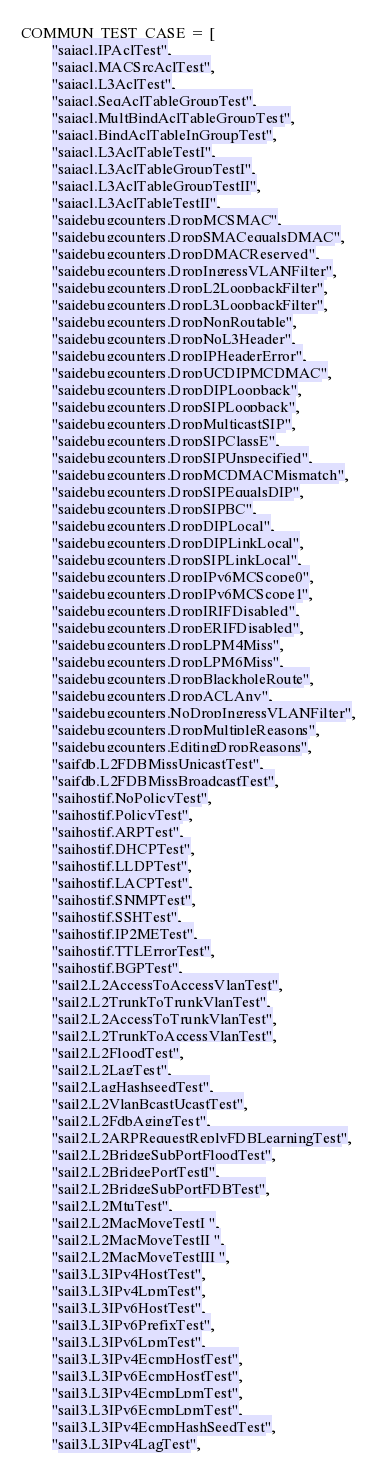<code> <loc_0><loc_0><loc_500><loc_500><_Python_>COMMUN_TEST_CASE = [
        "saiacl.IPAclTest",
        "saiacl.MACSrcAclTest",
        "saiacl.L3AclTest",
        "saiacl.SeqAclTableGroupTest",
        "saiacl.MultBindAclTableGroupTest",
        "saiacl.BindAclTableInGroupTest",
        "saiacl.L3AclTableTestI",
        "saiacl.L3AclTableGroupTestI",
        "saiacl.L3AclTableGroupTestII",
        "saiacl.L3AclTableTestII",
        "saidebugcounters.DropMCSMAC",
        "saidebugcounters.DropSMACequalsDMAC",
        "saidebugcounters.DropDMACReserved",
        "saidebugcounters.DropIngressVLANFilter",
        "saidebugcounters.DropL2LoopbackFilter",
        "saidebugcounters.DropL3LoopbackFilter",
        "saidebugcounters.DropNonRoutable",
        "saidebugcounters.DropNoL3Header",
        "saidebugcounters.DropIPHeaderError",
        "saidebugcounters.DropUCDIPMCDMAC",
        "saidebugcounters.DropDIPLoopback",
        "saidebugcounters.DropSIPLoopback",
        "saidebugcounters.DropMulticastSIP",
        "saidebugcounters.DropSIPClassE",
        "saidebugcounters.DropSIPUnspecified",
        "saidebugcounters.DropMCDMACMismatch",
        "saidebugcounters.DropSIPEqualsDIP",
        "saidebugcounters.DropSIPBC",
        "saidebugcounters.DropDIPLocal",
        "saidebugcounters.DropDIPLinkLocal",
        "saidebugcounters.DropSIPLinkLocal",
        "saidebugcounters.DropIPv6MCScope0",
        "saidebugcounters.DropIPv6MCScope1",
        "saidebugcounters.DropIRIFDisabled",
        "saidebugcounters.DropERIFDisabled",
        "saidebugcounters.DropLPM4Miss",
        "saidebugcounters.DropLPM6Miss",
        "saidebugcounters.DropBlackholeRoute",
        "saidebugcounters.DropACLAny",
        "saidebugcounters.NoDropIngressVLANFilter",
        "saidebugcounters.DropMultipleReasons",
        "saidebugcounters.EditingDropReasons",
        "saifdb.L2FDBMissUnicastTest",
        "saifdb.L2FDBMissBroadcastTest",
        "saihostif.NoPolicyTest",
        "saihostif.PolicyTest",
        "saihostif.ARPTest",
        "saihostif.DHCPTest",
        "saihostif.LLDPTest",
        "saihostif.LACPTest",
        "saihostif.SNMPTest",
        "saihostif.SSHTest",
        "saihostif.IP2METest",
        "saihostif.TTLErrorTest",
        "saihostif.BGPTest",
        "sail2.L2AccessToAccessVlanTest",
        "sail2.L2TrunkToTrunkVlanTest",
        "sail2.L2AccessToTrunkVlanTest",
        "sail2.L2TrunkToAccessVlanTest",
        "sail2.L2FloodTest",
        "sail2.L2LagTest",
        "sail2.LagHashseedTest",
        "sail2.L2VlanBcastUcastTest",
        "sail2.L2FdbAgingTest",
        "sail2.L2ARPRequestReplyFDBLearningTest",
        "sail2.L2BridgeSubPortFloodTest",
        "sail2.L2BridgePortTestI",
        "sail2.L2BridgeSubPortFDBTest",
        "sail2.L2MtuTest",
        "sail2.L2MacMoveTestI ",
        "sail2.L2MacMoveTestII ",
        "sail2.L2MacMoveTestIII ",
        "sail3.L3IPv4HostTest",
        "sail3.L3IPv4LpmTest",
        "sail3.L3IPv6HostTest",
        "sail3.L3IPv6PrefixTest",
        "sail3.L3IPv6LpmTest",
        "sail3.L3IPv4EcmpHostTest",
        "sail3.L3IPv6EcmpHostTest",
        "sail3.L3IPv4EcmpLpmTest",
        "sail3.L3IPv6EcmpLpmTest",
        "sail3.L3IPv4EcmpHashSeedTest",
        "sail3.L3IPv4LagTest",</code> 